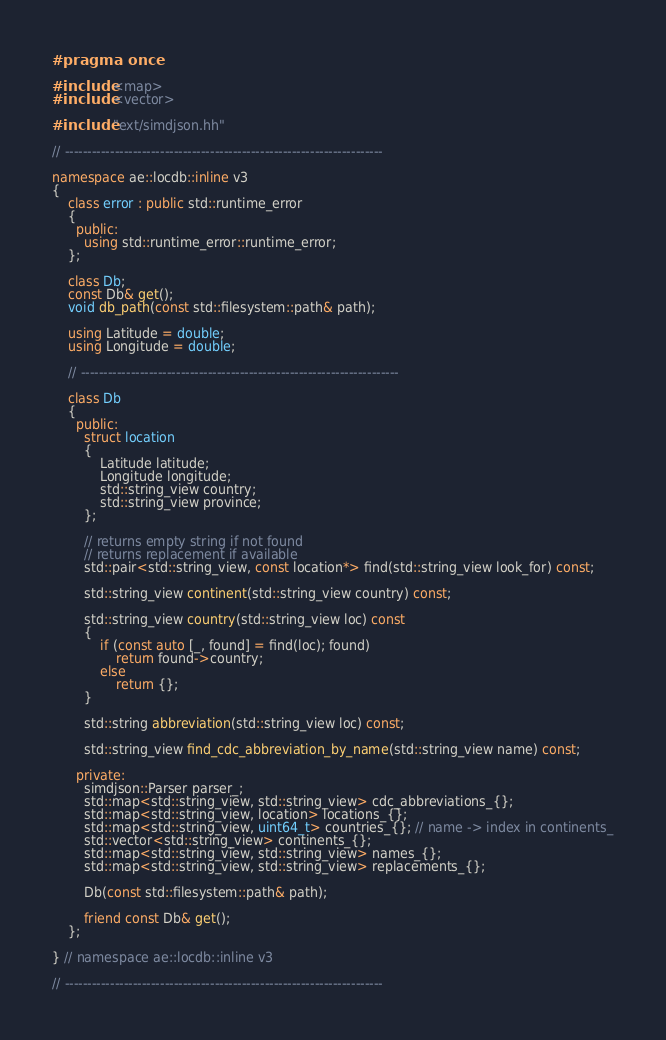Convert code to text. <code><loc_0><loc_0><loc_500><loc_500><_C++_>#pragma once

#include <map>
#include <vector>

#include "ext/simdjson.hh"

// ----------------------------------------------------------------------

namespace ae::locdb::inline v3
{
    class error : public std::runtime_error
    {
      public:
        using std::runtime_error::runtime_error;
    };

    class Db;
    const Db& get();
    void db_path(const std::filesystem::path& path);

    using Latitude = double;
    using Longitude = double;

    // ----------------------------------------------------------------------

    class Db
    {
      public:
        struct location
        {
            Latitude latitude;
            Longitude longitude;
            std::string_view country;
            std::string_view province;
        };

        // returns empty string if not found
        // returns replacement if available
        std::pair<std::string_view, const location*> find(std::string_view look_for) const;

        std::string_view continent(std::string_view country) const;

        std::string_view country(std::string_view loc) const
        {
            if (const auto [_, found] = find(loc); found)
                return found->country;
            else
                return {};
        }

        std::string abbreviation(std::string_view loc) const;

        std::string_view find_cdc_abbreviation_by_name(std::string_view name) const;

      private:
        simdjson::Parser parser_;
        std::map<std::string_view, std::string_view> cdc_abbreviations_{};
        std::map<std::string_view, location> locations_{};
        std::map<std::string_view, uint64_t> countries_{}; // name -> index in continents_
        std::vector<std::string_view> continents_{};
        std::map<std::string_view, std::string_view> names_{};
        std::map<std::string_view, std::string_view> replacements_{};

        Db(const std::filesystem::path& path);

        friend const Db& get();
    };

} // namespace ae::locdb::inline v3

// ----------------------------------------------------------------------
</code> 